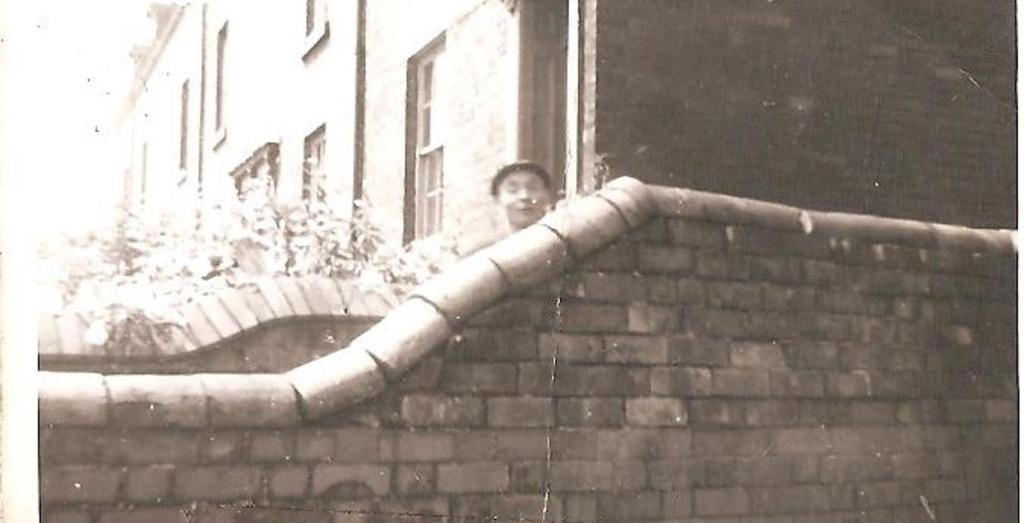What is the color scheme of the image? The image is black and white. What type of structure is visible in the image? There is a wall of a building in the image. Can you describe the presence of a person in the image? There is a person behind the wall in the image. What type of natural element is present in the image? There is a tree in the image. How many books can be seen on the tree in the image? There are no books present in the image, and the tree does not have any books on it. 